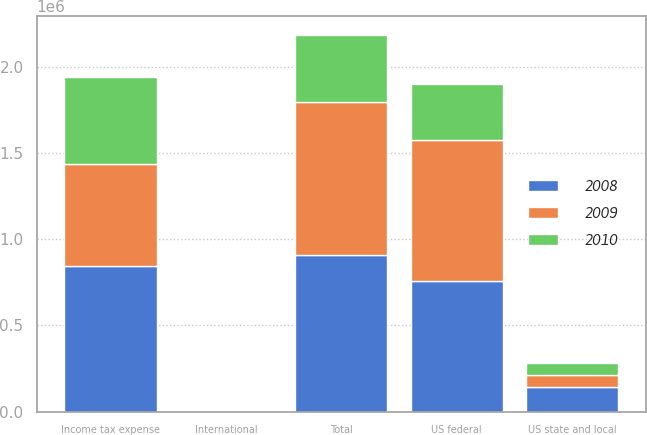<chart> <loc_0><loc_0><loc_500><loc_500><stacked_bar_chart><ecel><fcel>US federal<fcel>US state and local<fcel>International<fcel>Total<fcel>Income tax expense<nl><fcel>2010<fcel>320739<fcel>68313<fcel>2438<fcel>391490<fcel>504071<nl><fcel>2008<fcel>759683<fcel>143610<fcel>3415<fcel>906708<fcel>844713<nl><fcel>2009<fcel>820180<fcel>67696<fcel>907<fcel>888783<fcel>594692<nl></chart> 